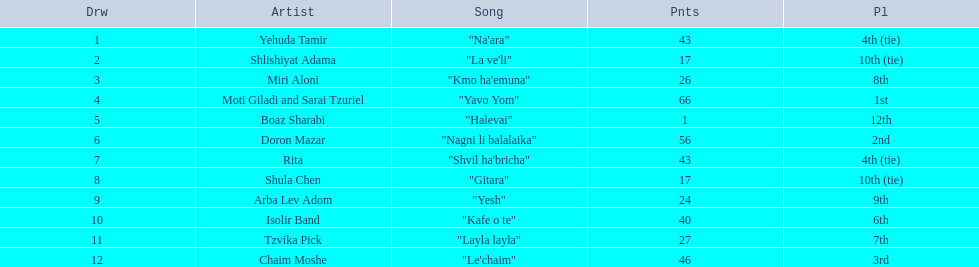What artist received the least amount of points in the competition? Boaz Sharabi. 